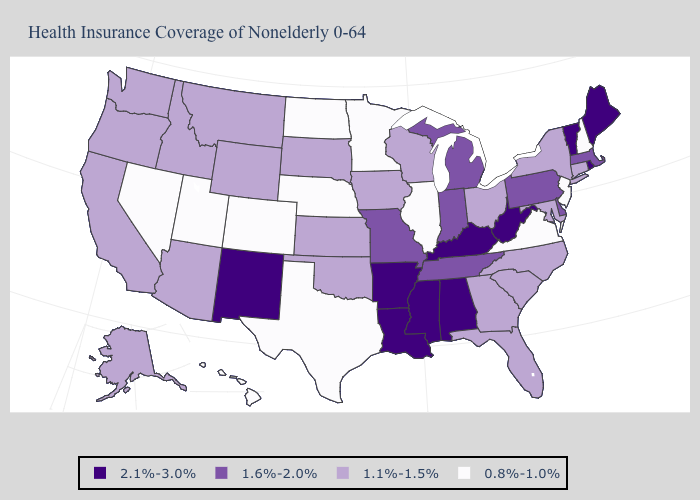What is the value of New Jersey?
Concise answer only. 0.8%-1.0%. Name the states that have a value in the range 0.8%-1.0%?
Keep it brief. Colorado, Hawaii, Illinois, Minnesota, Nebraska, Nevada, New Hampshire, New Jersey, North Dakota, Texas, Utah, Virginia. Does the map have missing data?
Write a very short answer. No. Which states have the lowest value in the USA?
Give a very brief answer. Colorado, Hawaii, Illinois, Minnesota, Nebraska, Nevada, New Hampshire, New Jersey, North Dakota, Texas, Utah, Virginia. Does Missouri have a lower value than Texas?
Answer briefly. No. What is the value of New York?
Answer briefly. 1.1%-1.5%. Does Iowa have the highest value in the MidWest?
Write a very short answer. No. Among the states that border Louisiana , which have the highest value?
Write a very short answer. Arkansas, Mississippi. Does North Dakota have the highest value in the MidWest?
Concise answer only. No. Name the states that have a value in the range 1.1%-1.5%?
Short answer required. Alaska, Arizona, California, Connecticut, Florida, Georgia, Idaho, Iowa, Kansas, Maryland, Montana, New York, North Carolina, Ohio, Oklahoma, Oregon, South Carolina, South Dakota, Washington, Wisconsin, Wyoming. How many symbols are there in the legend?
Keep it brief. 4. What is the value of Missouri?
Answer briefly. 1.6%-2.0%. What is the value of South Carolina?
Concise answer only. 1.1%-1.5%. Which states have the lowest value in the South?
Write a very short answer. Texas, Virginia. 